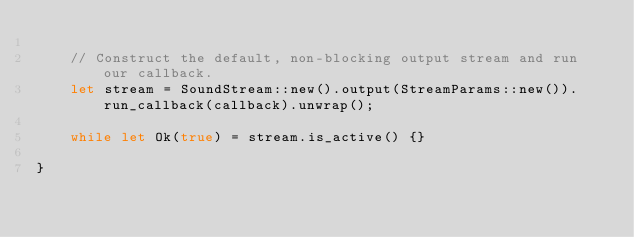<code> <loc_0><loc_0><loc_500><loc_500><_Rust_>
    // Construct the default, non-blocking output stream and run our callback.
    let stream = SoundStream::new().output(StreamParams::new()).run_callback(callback).unwrap();

    while let Ok(true) = stream.is_active() {}

}

</code> 